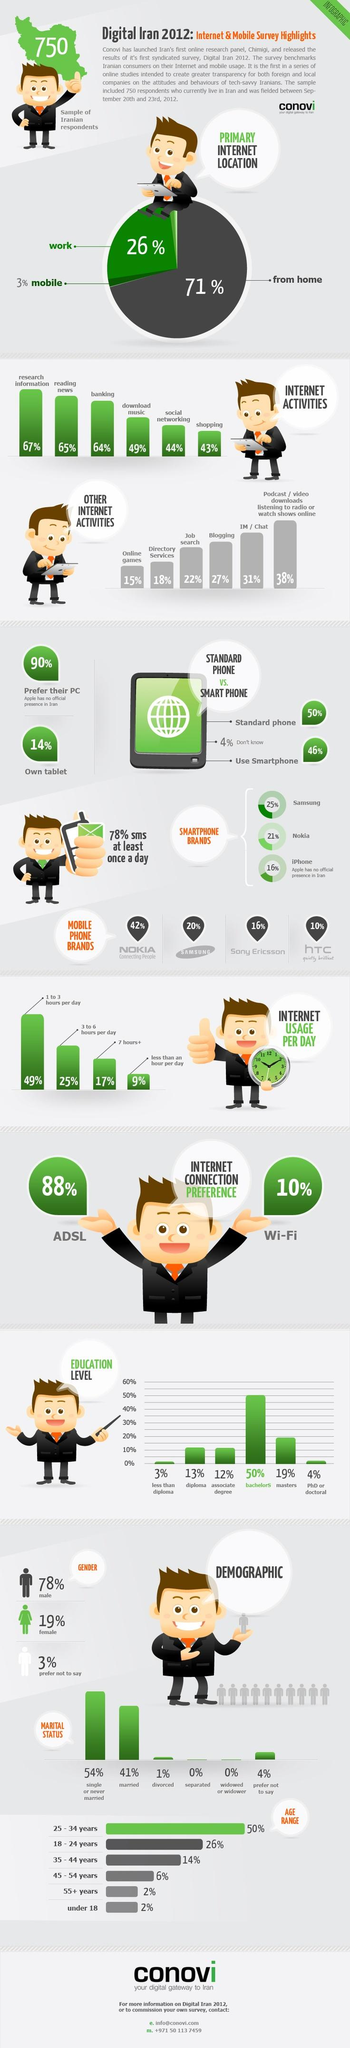Outline some significant characteristics in this image. PhD holders or those with a Doctoral degree use the second least percentage of the internet out of all education categories. It is estimated that approximately 20% of mobile phone users use the brand Samsung. According to the data, approximately 25% of internet users spend 3 to 6 hours per day on the internet. The 55+ age group and those under the age of 18 have a very low internet usage rate, at only 2%, according to the provided data. In Iran, approximately 65% of users access the internet through their mobile devices. 